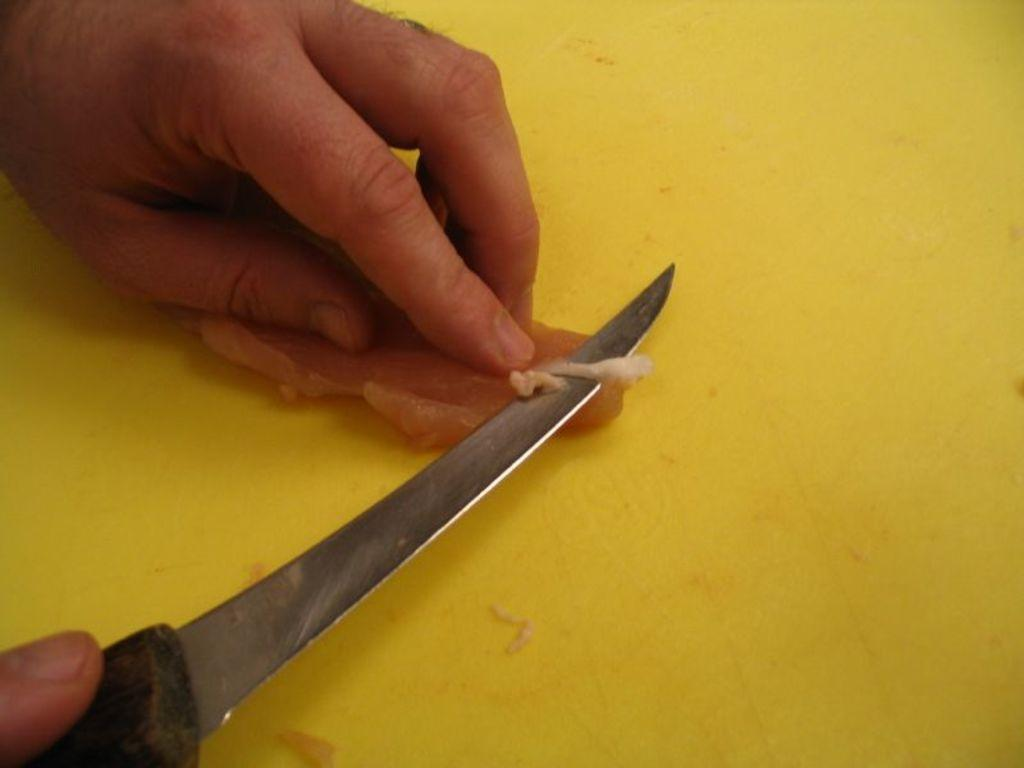What can be seen in the image? There is a human hand in the image. What is the hand holding? The hand is holding a knife. What is the knife being used for? The knife is being used to cut meat. What type of school can be seen in the image? There is no school present in the image; it features a human hand holding a knife to cut meat. 